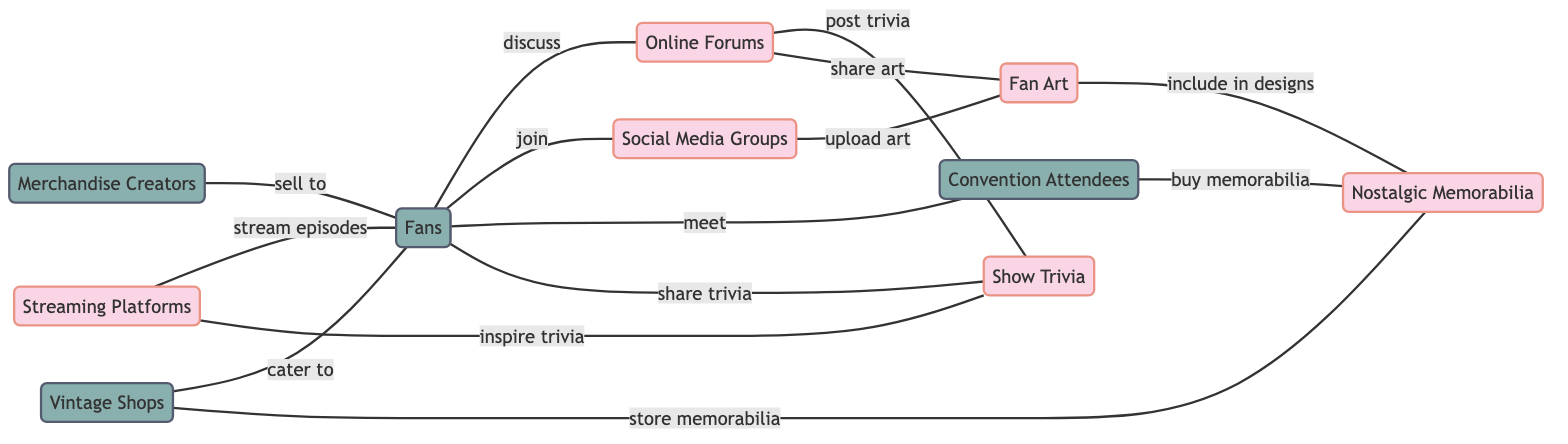What's the total number of nodes in the diagram? By counting the nodes listed in the diagram, we find there are 10 distinct entities represented. The nodes are: Fans, Merchandise Creators, Online Forums, Social Media Groups, Convention Attendees, Vintage Shops, Streaming Platforms, Show Trivia, Fan Art, and Nostalgic Memorabilia.
Answer: 10 Which nodes are directly related to Fans? The diagram shows five edges connecting to Fans. The related nodes are: Online Forums (discuss), Social Media Groups (join), Convention Attendees (meet), Show Trivia (share trivia), and Vintage Shops (cater to).
Answer: 5 What type of interaction occurs between Online Forums and Show Trivia? The edge connecting Online Forums to Show Trivia indicates the action of posting trivia, which represents how these two nodes interact with each other. This relationship signifies that Online Forums serve as a platform for users to share information about the show's trivia.
Answer: post trivia Which node connects to Nostalgic Memorabilia through Convention Attendees? The connection from Convention Attendees to Nostalgic Memorabilia indicates an interaction where fans purchase memorabilia at conventions. This illustrates the relationship between event attendance and acquiring themed items.
Answer: buy memorabilia How many interactions are represented between Fans and Merchandise Creators? There are two distinct interactions: Merchandise Creators sell to Fans and Fans contribute to the discussion within the fan community, indicating a two-way relationship.
Answer: 1 Which node is linked to Fan Art with the action of uploading art? The Social Media Groups node connects to Fan Art by indicating the action of uploading art. This suggests that members of social media groups commonly share their artistic creations relating to the show within these platforms.
Answer: upload art What is the total number of edges in the diagram? By counting all the described interactions (edges) connecting the nodes, there are a total of 12 edges that demonstrate the various relationships within the community.
Answer: 12 Which nodes are connected through the action of including in designs? The connection between Fan Art and Nostalgic Memorabilia shows that Fan Art includes elements that may be used in creating or designing Nostalgic Memorabilia, thereby illustrating the collaboration between these two aspects.
Answer: include in designs What is the action connecting Streaming Platforms and Fans? The edge from Streaming Platforms to Fans indicates the action of streaming episodes, which represents how fans engage with the show through various digital platforms.
Answer: stream episodes 